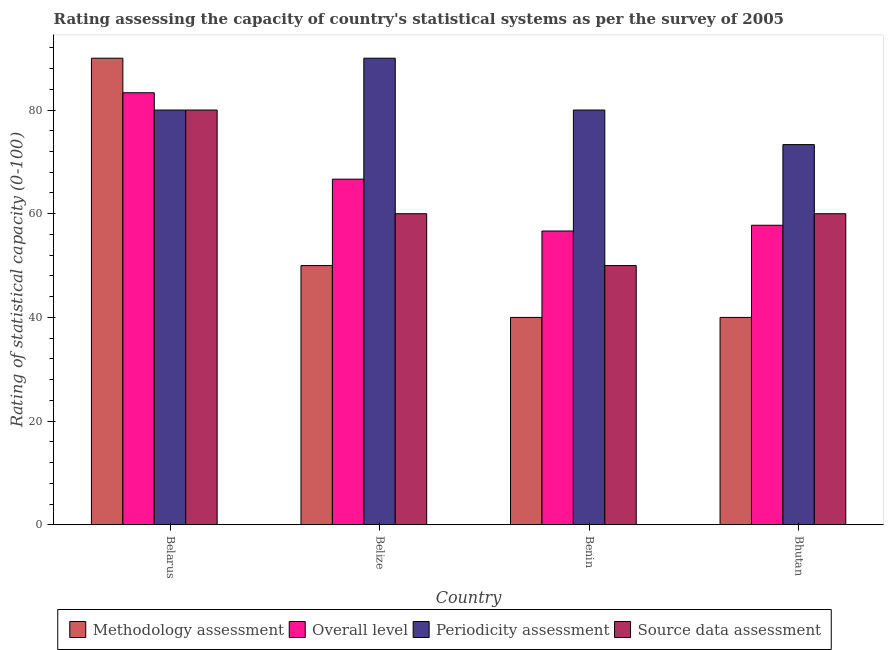How many different coloured bars are there?
Your answer should be very brief. 4. How many bars are there on the 4th tick from the left?
Make the answer very short. 4. What is the label of the 2nd group of bars from the left?
Provide a succinct answer. Belize. What is the source data assessment rating in Belize?
Your answer should be compact. 60. Across all countries, what is the minimum periodicity assessment rating?
Your response must be concise. 73.33. In which country was the methodology assessment rating maximum?
Offer a very short reply. Belarus. In which country was the source data assessment rating minimum?
Keep it short and to the point. Benin. What is the total periodicity assessment rating in the graph?
Make the answer very short. 323.33. What is the difference between the periodicity assessment rating in Benin and that in Bhutan?
Provide a short and direct response. 6.67. What is the difference between the periodicity assessment rating in Benin and the overall level rating in Bhutan?
Your answer should be very brief. 22.22. What is the average periodicity assessment rating per country?
Your answer should be very brief. 80.83. What is the difference between the methodology assessment rating and overall level rating in Benin?
Make the answer very short. -16.67. In how many countries, is the source data assessment rating greater than 24 ?
Your answer should be very brief. 4. What is the ratio of the methodology assessment rating in Belize to that in Bhutan?
Offer a very short reply. 1.25. Is the overall level rating in Belarus less than that in Belize?
Keep it short and to the point. No. What is the difference between the highest and the second highest source data assessment rating?
Your answer should be very brief. 20. What is the difference between the highest and the lowest overall level rating?
Provide a succinct answer. 26.67. Is it the case that in every country, the sum of the overall level rating and periodicity assessment rating is greater than the sum of methodology assessment rating and source data assessment rating?
Offer a very short reply. No. What does the 1st bar from the left in Benin represents?
Ensure brevity in your answer.  Methodology assessment. What does the 1st bar from the right in Belize represents?
Offer a terse response. Source data assessment. Is it the case that in every country, the sum of the methodology assessment rating and overall level rating is greater than the periodicity assessment rating?
Your answer should be compact. Yes. Are all the bars in the graph horizontal?
Offer a terse response. No. What is the difference between two consecutive major ticks on the Y-axis?
Your response must be concise. 20. Are the values on the major ticks of Y-axis written in scientific E-notation?
Your response must be concise. No. Does the graph contain any zero values?
Offer a very short reply. No. What is the title of the graph?
Your answer should be compact. Rating assessing the capacity of country's statistical systems as per the survey of 2005 . What is the label or title of the Y-axis?
Keep it short and to the point. Rating of statistical capacity (0-100). What is the Rating of statistical capacity (0-100) in Methodology assessment in Belarus?
Offer a very short reply. 90. What is the Rating of statistical capacity (0-100) in Overall level in Belarus?
Your answer should be very brief. 83.33. What is the Rating of statistical capacity (0-100) in Overall level in Belize?
Provide a succinct answer. 66.67. What is the Rating of statistical capacity (0-100) in Periodicity assessment in Belize?
Keep it short and to the point. 90. What is the Rating of statistical capacity (0-100) of Overall level in Benin?
Provide a succinct answer. 56.67. What is the Rating of statistical capacity (0-100) of Methodology assessment in Bhutan?
Your response must be concise. 40. What is the Rating of statistical capacity (0-100) in Overall level in Bhutan?
Offer a very short reply. 57.78. What is the Rating of statistical capacity (0-100) in Periodicity assessment in Bhutan?
Your answer should be very brief. 73.33. What is the Rating of statistical capacity (0-100) of Source data assessment in Bhutan?
Ensure brevity in your answer.  60. Across all countries, what is the maximum Rating of statistical capacity (0-100) of Methodology assessment?
Your answer should be very brief. 90. Across all countries, what is the maximum Rating of statistical capacity (0-100) of Overall level?
Provide a short and direct response. 83.33. Across all countries, what is the maximum Rating of statistical capacity (0-100) of Source data assessment?
Provide a succinct answer. 80. Across all countries, what is the minimum Rating of statistical capacity (0-100) in Overall level?
Offer a terse response. 56.67. Across all countries, what is the minimum Rating of statistical capacity (0-100) in Periodicity assessment?
Ensure brevity in your answer.  73.33. Across all countries, what is the minimum Rating of statistical capacity (0-100) in Source data assessment?
Your answer should be compact. 50. What is the total Rating of statistical capacity (0-100) of Methodology assessment in the graph?
Your answer should be compact. 220. What is the total Rating of statistical capacity (0-100) of Overall level in the graph?
Provide a succinct answer. 264.44. What is the total Rating of statistical capacity (0-100) in Periodicity assessment in the graph?
Offer a very short reply. 323.33. What is the total Rating of statistical capacity (0-100) of Source data assessment in the graph?
Offer a very short reply. 250. What is the difference between the Rating of statistical capacity (0-100) in Overall level in Belarus and that in Belize?
Your answer should be compact. 16.67. What is the difference between the Rating of statistical capacity (0-100) of Source data assessment in Belarus and that in Belize?
Offer a very short reply. 20. What is the difference between the Rating of statistical capacity (0-100) in Methodology assessment in Belarus and that in Benin?
Provide a short and direct response. 50. What is the difference between the Rating of statistical capacity (0-100) in Overall level in Belarus and that in Benin?
Keep it short and to the point. 26.67. What is the difference between the Rating of statistical capacity (0-100) of Periodicity assessment in Belarus and that in Benin?
Provide a short and direct response. 0. What is the difference between the Rating of statistical capacity (0-100) in Source data assessment in Belarus and that in Benin?
Give a very brief answer. 30. What is the difference between the Rating of statistical capacity (0-100) in Methodology assessment in Belarus and that in Bhutan?
Keep it short and to the point. 50. What is the difference between the Rating of statistical capacity (0-100) in Overall level in Belarus and that in Bhutan?
Your answer should be very brief. 25.56. What is the difference between the Rating of statistical capacity (0-100) in Periodicity assessment in Belarus and that in Bhutan?
Your answer should be compact. 6.67. What is the difference between the Rating of statistical capacity (0-100) of Methodology assessment in Belize and that in Benin?
Your response must be concise. 10. What is the difference between the Rating of statistical capacity (0-100) of Overall level in Belize and that in Benin?
Ensure brevity in your answer.  10. What is the difference between the Rating of statistical capacity (0-100) in Methodology assessment in Belize and that in Bhutan?
Keep it short and to the point. 10. What is the difference between the Rating of statistical capacity (0-100) of Overall level in Belize and that in Bhutan?
Offer a terse response. 8.89. What is the difference between the Rating of statistical capacity (0-100) of Periodicity assessment in Belize and that in Bhutan?
Keep it short and to the point. 16.67. What is the difference between the Rating of statistical capacity (0-100) of Source data assessment in Belize and that in Bhutan?
Your response must be concise. 0. What is the difference between the Rating of statistical capacity (0-100) of Methodology assessment in Benin and that in Bhutan?
Keep it short and to the point. 0. What is the difference between the Rating of statistical capacity (0-100) of Overall level in Benin and that in Bhutan?
Make the answer very short. -1.11. What is the difference between the Rating of statistical capacity (0-100) of Source data assessment in Benin and that in Bhutan?
Offer a very short reply. -10. What is the difference between the Rating of statistical capacity (0-100) of Methodology assessment in Belarus and the Rating of statistical capacity (0-100) of Overall level in Belize?
Your response must be concise. 23.33. What is the difference between the Rating of statistical capacity (0-100) in Methodology assessment in Belarus and the Rating of statistical capacity (0-100) in Source data assessment in Belize?
Your answer should be very brief. 30. What is the difference between the Rating of statistical capacity (0-100) in Overall level in Belarus and the Rating of statistical capacity (0-100) in Periodicity assessment in Belize?
Give a very brief answer. -6.67. What is the difference between the Rating of statistical capacity (0-100) in Overall level in Belarus and the Rating of statistical capacity (0-100) in Source data assessment in Belize?
Your response must be concise. 23.33. What is the difference between the Rating of statistical capacity (0-100) of Methodology assessment in Belarus and the Rating of statistical capacity (0-100) of Overall level in Benin?
Ensure brevity in your answer.  33.33. What is the difference between the Rating of statistical capacity (0-100) of Overall level in Belarus and the Rating of statistical capacity (0-100) of Periodicity assessment in Benin?
Offer a very short reply. 3.33. What is the difference between the Rating of statistical capacity (0-100) of Overall level in Belarus and the Rating of statistical capacity (0-100) of Source data assessment in Benin?
Provide a succinct answer. 33.33. What is the difference between the Rating of statistical capacity (0-100) of Methodology assessment in Belarus and the Rating of statistical capacity (0-100) of Overall level in Bhutan?
Offer a very short reply. 32.22. What is the difference between the Rating of statistical capacity (0-100) of Methodology assessment in Belarus and the Rating of statistical capacity (0-100) of Periodicity assessment in Bhutan?
Your response must be concise. 16.67. What is the difference between the Rating of statistical capacity (0-100) of Methodology assessment in Belarus and the Rating of statistical capacity (0-100) of Source data assessment in Bhutan?
Your answer should be compact. 30. What is the difference between the Rating of statistical capacity (0-100) of Overall level in Belarus and the Rating of statistical capacity (0-100) of Source data assessment in Bhutan?
Make the answer very short. 23.33. What is the difference between the Rating of statistical capacity (0-100) in Periodicity assessment in Belarus and the Rating of statistical capacity (0-100) in Source data assessment in Bhutan?
Offer a very short reply. 20. What is the difference between the Rating of statistical capacity (0-100) in Methodology assessment in Belize and the Rating of statistical capacity (0-100) in Overall level in Benin?
Your response must be concise. -6.67. What is the difference between the Rating of statistical capacity (0-100) in Methodology assessment in Belize and the Rating of statistical capacity (0-100) in Periodicity assessment in Benin?
Keep it short and to the point. -30. What is the difference between the Rating of statistical capacity (0-100) in Overall level in Belize and the Rating of statistical capacity (0-100) in Periodicity assessment in Benin?
Make the answer very short. -13.33. What is the difference between the Rating of statistical capacity (0-100) in Overall level in Belize and the Rating of statistical capacity (0-100) in Source data assessment in Benin?
Provide a short and direct response. 16.67. What is the difference between the Rating of statistical capacity (0-100) in Methodology assessment in Belize and the Rating of statistical capacity (0-100) in Overall level in Bhutan?
Ensure brevity in your answer.  -7.78. What is the difference between the Rating of statistical capacity (0-100) in Methodology assessment in Belize and the Rating of statistical capacity (0-100) in Periodicity assessment in Bhutan?
Provide a succinct answer. -23.33. What is the difference between the Rating of statistical capacity (0-100) of Overall level in Belize and the Rating of statistical capacity (0-100) of Periodicity assessment in Bhutan?
Your response must be concise. -6.67. What is the difference between the Rating of statistical capacity (0-100) of Periodicity assessment in Belize and the Rating of statistical capacity (0-100) of Source data assessment in Bhutan?
Keep it short and to the point. 30. What is the difference between the Rating of statistical capacity (0-100) of Methodology assessment in Benin and the Rating of statistical capacity (0-100) of Overall level in Bhutan?
Make the answer very short. -17.78. What is the difference between the Rating of statistical capacity (0-100) in Methodology assessment in Benin and the Rating of statistical capacity (0-100) in Periodicity assessment in Bhutan?
Your response must be concise. -33.33. What is the difference between the Rating of statistical capacity (0-100) in Overall level in Benin and the Rating of statistical capacity (0-100) in Periodicity assessment in Bhutan?
Your response must be concise. -16.67. What is the difference between the Rating of statistical capacity (0-100) in Overall level in Benin and the Rating of statistical capacity (0-100) in Source data assessment in Bhutan?
Ensure brevity in your answer.  -3.33. What is the difference between the Rating of statistical capacity (0-100) of Periodicity assessment in Benin and the Rating of statistical capacity (0-100) of Source data assessment in Bhutan?
Ensure brevity in your answer.  20. What is the average Rating of statistical capacity (0-100) of Methodology assessment per country?
Your response must be concise. 55. What is the average Rating of statistical capacity (0-100) in Overall level per country?
Provide a short and direct response. 66.11. What is the average Rating of statistical capacity (0-100) of Periodicity assessment per country?
Keep it short and to the point. 80.83. What is the average Rating of statistical capacity (0-100) in Source data assessment per country?
Offer a very short reply. 62.5. What is the difference between the Rating of statistical capacity (0-100) of Methodology assessment and Rating of statistical capacity (0-100) of Overall level in Belarus?
Offer a terse response. 6.67. What is the difference between the Rating of statistical capacity (0-100) of Overall level and Rating of statistical capacity (0-100) of Periodicity assessment in Belarus?
Provide a succinct answer. 3.33. What is the difference between the Rating of statistical capacity (0-100) in Overall level and Rating of statistical capacity (0-100) in Source data assessment in Belarus?
Keep it short and to the point. 3.33. What is the difference between the Rating of statistical capacity (0-100) of Methodology assessment and Rating of statistical capacity (0-100) of Overall level in Belize?
Offer a very short reply. -16.67. What is the difference between the Rating of statistical capacity (0-100) in Methodology assessment and Rating of statistical capacity (0-100) in Periodicity assessment in Belize?
Provide a succinct answer. -40. What is the difference between the Rating of statistical capacity (0-100) of Methodology assessment and Rating of statistical capacity (0-100) of Source data assessment in Belize?
Ensure brevity in your answer.  -10. What is the difference between the Rating of statistical capacity (0-100) of Overall level and Rating of statistical capacity (0-100) of Periodicity assessment in Belize?
Keep it short and to the point. -23.33. What is the difference between the Rating of statistical capacity (0-100) in Periodicity assessment and Rating of statistical capacity (0-100) in Source data assessment in Belize?
Your answer should be compact. 30. What is the difference between the Rating of statistical capacity (0-100) of Methodology assessment and Rating of statistical capacity (0-100) of Overall level in Benin?
Provide a succinct answer. -16.67. What is the difference between the Rating of statistical capacity (0-100) of Methodology assessment and Rating of statistical capacity (0-100) of Source data assessment in Benin?
Your answer should be very brief. -10. What is the difference between the Rating of statistical capacity (0-100) in Overall level and Rating of statistical capacity (0-100) in Periodicity assessment in Benin?
Your answer should be very brief. -23.33. What is the difference between the Rating of statistical capacity (0-100) of Overall level and Rating of statistical capacity (0-100) of Source data assessment in Benin?
Your response must be concise. 6.67. What is the difference between the Rating of statistical capacity (0-100) in Periodicity assessment and Rating of statistical capacity (0-100) in Source data assessment in Benin?
Give a very brief answer. 30. What is the difference between the Rating of statistical capacity (0-100) of Methodology assessment and Rating of statistical capacity (0-100) of Overall level in Bhutan?
Keep it short and to the point. -17.78. What is the difference between the Rating of statistical capacity (0-100) in Methodology assessment and Rating of statistical capacity (0-100) in Periodicity assessment in Bhutan?
Keep it short and to the point. -33.33. What is the difference between the Rating of statistical capacity (0-100) of Overall level and Rating of statistical capacity (0-100) of Periodicity assessment in Bhutan?
Keep it short and to the point. -15.56. What is the difference between the Rating of statistical capacity (0-100) of Overall level and Rating of statistical capacity (0-100) of Source data assessment in Bhutan?
Your answer should be very brief. -2.22. What is the difference between the Rating of statistical capacity (0-100) of Periodicity assessment and Rating of statistical capacity (0-100) of Source data assessment in Bhutan?
Keep it short and to the point. 13.33. What is the ratio of the Rating of statistical capacity (0-100) in Overall level in Belarus to that in Belize?
Give a very brief answer. 1.25. What is the ratio of the Rating of statistical capacity (0-100) in Periodicity assessment in Belarus to that in Belize?
Your response must be concise. 0.89. What is the ratio of the Rating of statistical capacity (0-100) in Methodology assessment in Belarus to that in Benin?
Provide a succinct answer. 2.25. What is the ratio of the Rating of statistical capacity (0-100) of Overall level in Belarus to that in Benin?
Your answer should be compact. 1.47. What is the ratio of the Rating of statistical capacity (0-100) of Periodicity assessment in Belarus to that in Benin?
Offer a very short reply. 1. What is the ratio of the Rating of statistical capacity (0-100) in Source data assessment in Belarus to that in Benin?
Your response must be concise. 1.6. What is the ratio of the Rating of statistical capacity (0-100) in Methodology assessment in Belarus to that in Bhutan?
Make the answer very short. 2.25. What is the ratio of the Rating of statistical capacity (0-100) of Overall level in Belarus to that in Bhutan?
Your response must be concise. 1.44. What is the ratio of the Rating of statistical capacity (0-100) in Periodicity assessment in Belarus to that in Bhutan?
Provide a succinct answer. 1.09. What is the ratio of the Rating of statistical capacity (0-100) in Overall level in Belize to that in Benin?
Your answer should be very brief. 1.18. What is the ratio of the Rating of statistical capacity (0-100) of Periodicity assessment in Belize to that in Benin?
Offer a terse response. 1.12. What is the ratio of the Rating of statistical capacity (0-100) in Source data assessment in Belize to that in Benin?
Ensure brevity in your answer.  1.2. What is the ratio of the Rating of statistical capacity (0-100) in Methodology assessment in Belize to that in Bhutan?
Ensure brevity in your answer.  1.25. What is the ratio of the Rating of statistical capacity (0-100) of Overall level in Belize to that in Bhutan?
Your answer should be very brief. 1.15. What is the ratio of the Rating of statistical capacity (0-100) in Periodicity assessment in Belize to that in Bhutan?
Provide a succinct answer. 1.23. What is the ratio of the Rating of statistical capacity (0-100) in Methodology assessment in Benin to that in Bhutan?
Your response must be concise. 1. What is the ratio of the Rating of statistical capacity (0-100) of Overall level in Benin to that in Bhutan?
Offer a terse response. 0.98. What is the difference between the highest and the second highest Rating of statistical capacity (0-100) in Overall level?
Ensure brevity in your answer.  16.67. What is the difference between the highest and the second highest Rating of statistical capacity (0-100) in Source data assessment?
Offer a terse response. 20. What is the difference between the highest and the lowest Rating of statistical capacity (0-100) in Methodology assessment?
Ensure brevity in your answer.  50. What is the difference between the highest and the lowest Rating of statistical capacity (0-100) of Overall level?
Keep it short and to the point. 26.67. What is the difference between the highest and the lowest Rating of statistical capacity (0-100) of Periodicity assessment?
Your response must be concise. 16.67. 